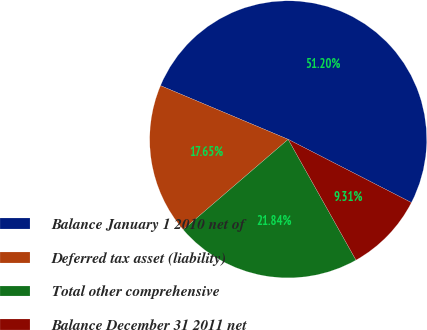Convert chart. <chart><loc_0><loc_0><loc_500><loc_500><pie_chart><fcel>Balance January 1 2010 net of<fcel>Deferred tax asset (liability)<fcel>Total other comprehensive<fcel>Balance December 31 2011 net<nl><fcel>51.21%<fcel>17.65%<fcel>21.84%<fcel>9.31%<nl></chart> 